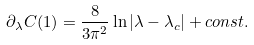Convert formula to latex. <formula><loc_0><loc_0><loc_500><loc_500>\partial _ { \lambda } C ( 1 ) = \frac { 8 } { 3 \pi ^ { 2 } } \ln | \lambda - \lambda _ { c } | + c o n s t .</formula> 